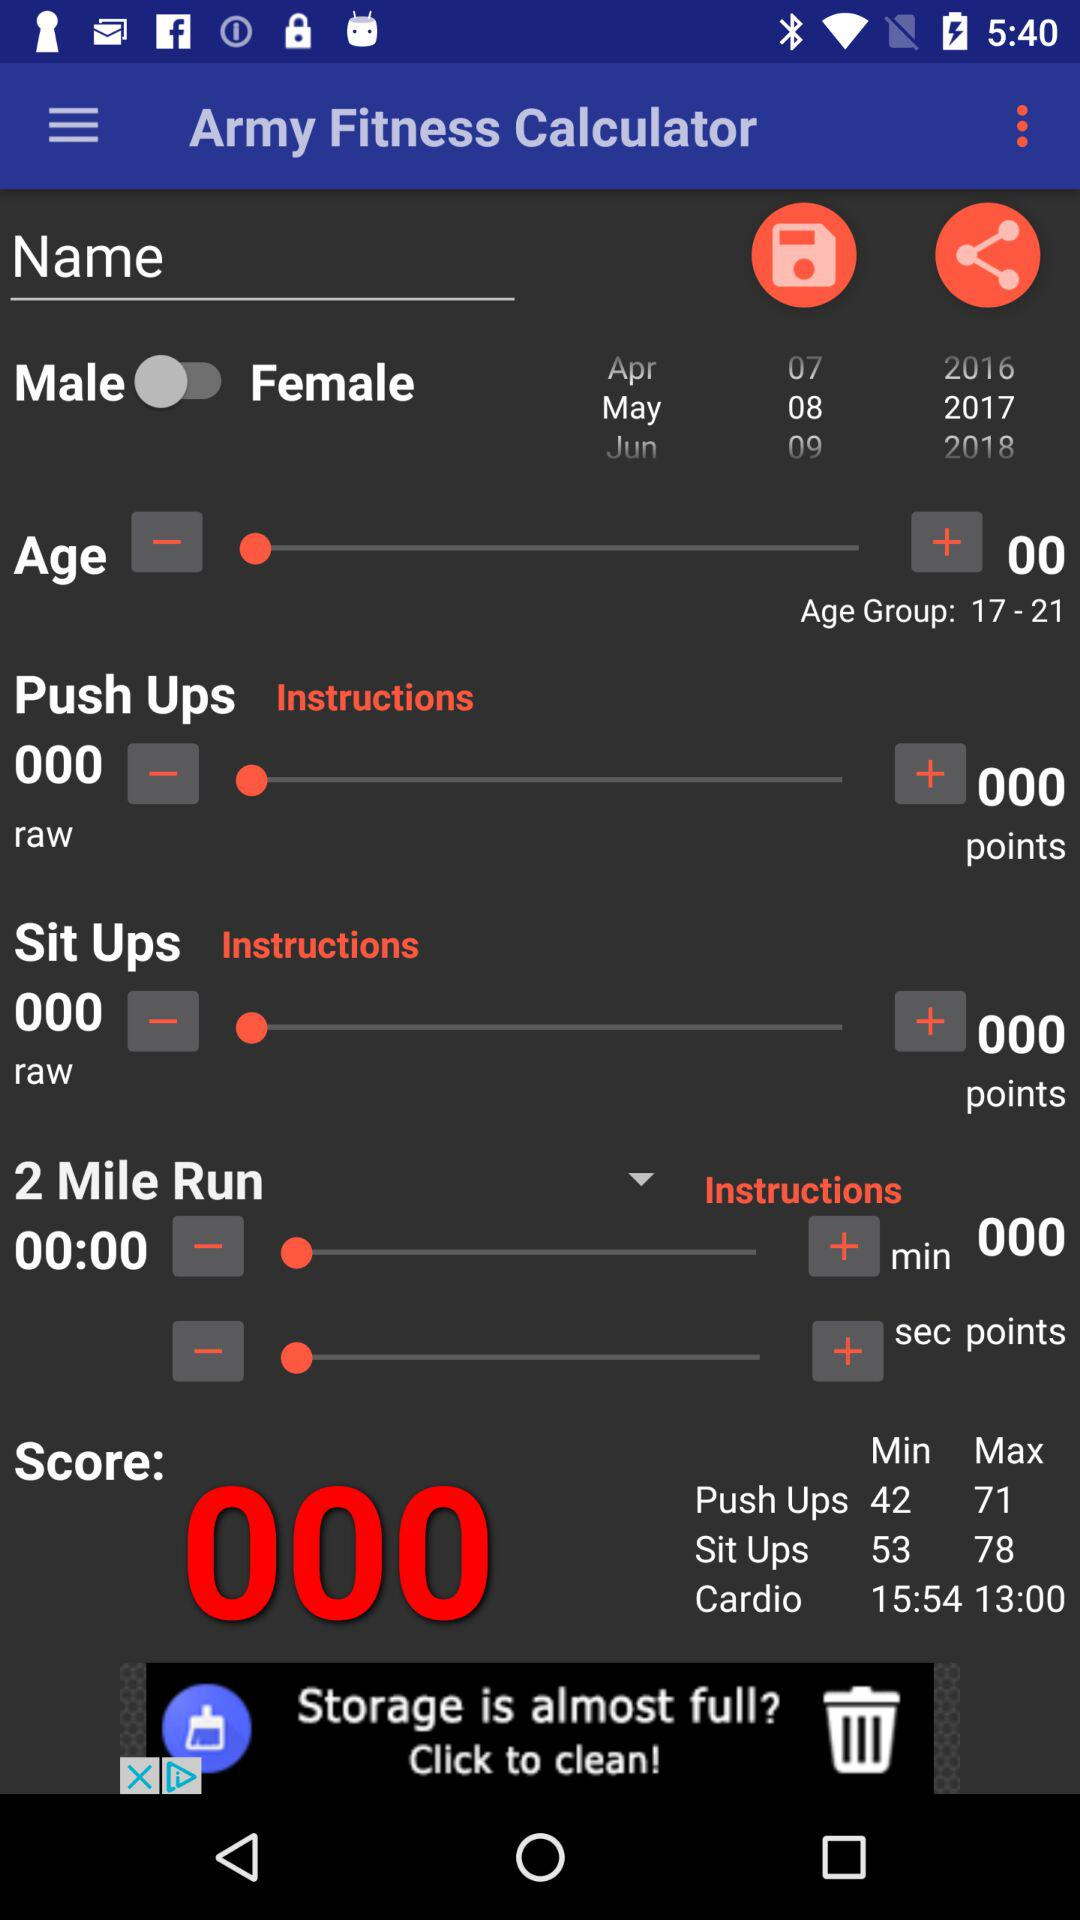What is the minimum and maximum duration of cardio? The minimum and maximum durations are 15 minutes 54 seconds and 13 minutes, respectively. 